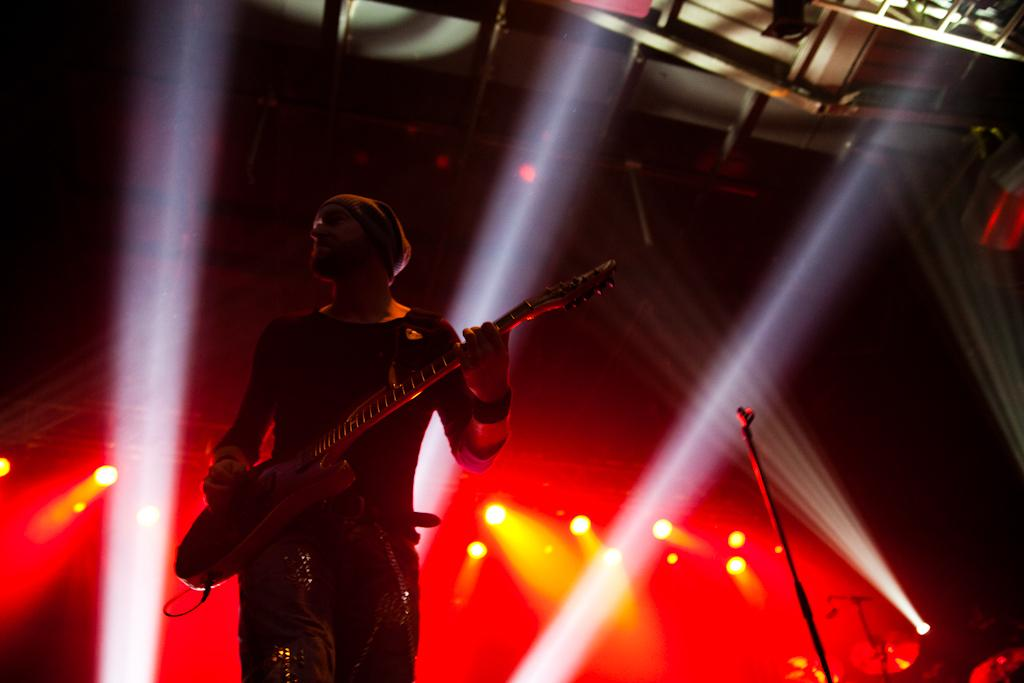Who is the main subject in the image? There is a man in the image. What is the man doing in the image? The man is playing a guitar in the image. Where is the man located in the image? The man is standing on a stage in the image. What can be seen in the background of the image? There are lights visible in the background of the image. What type of leather is the man wearing in the image? There is no mention of leather in the image, and the man's clothing is not described in the provided facts. 